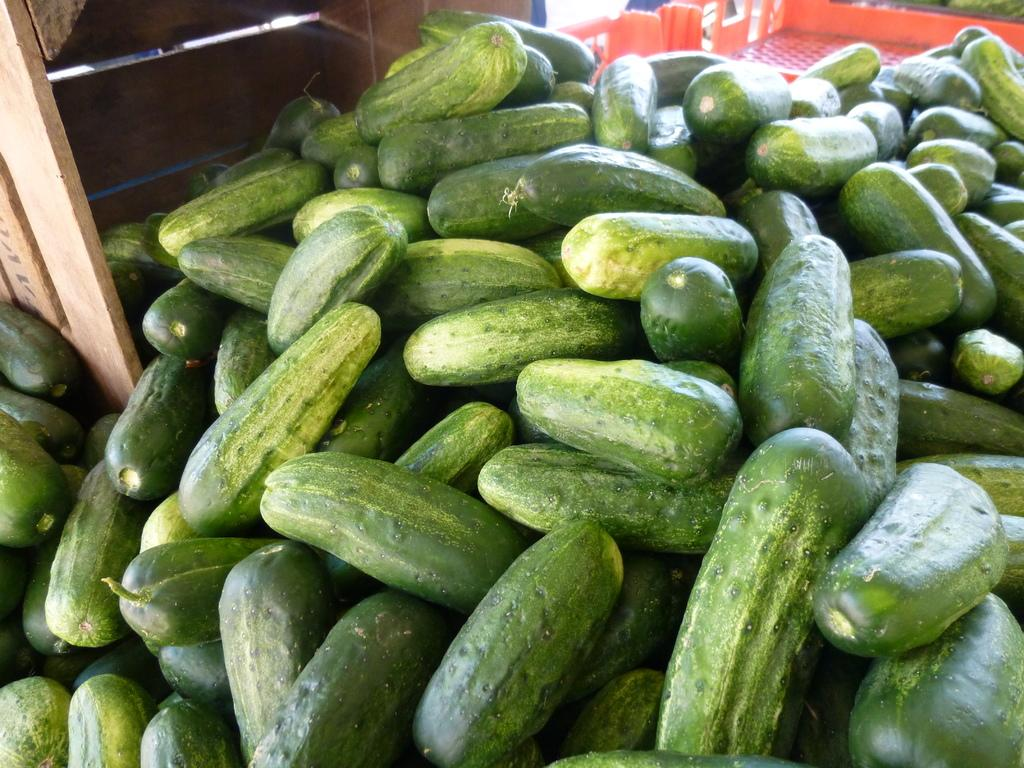What type of vegetable is in the foreground of the picture? There are cucumbers in the foreground of the picture. What object is also present in the foreground of the picture? There is a wooden basket in the foreground of the picture. What can be seen at the top of the picture? There are plastic trays at the top of the picture. How do the cucumbers express pain in the image? The cucumbers do not express pain in the image, as they are vegetables and do not have the ability to feel or express emotions. 